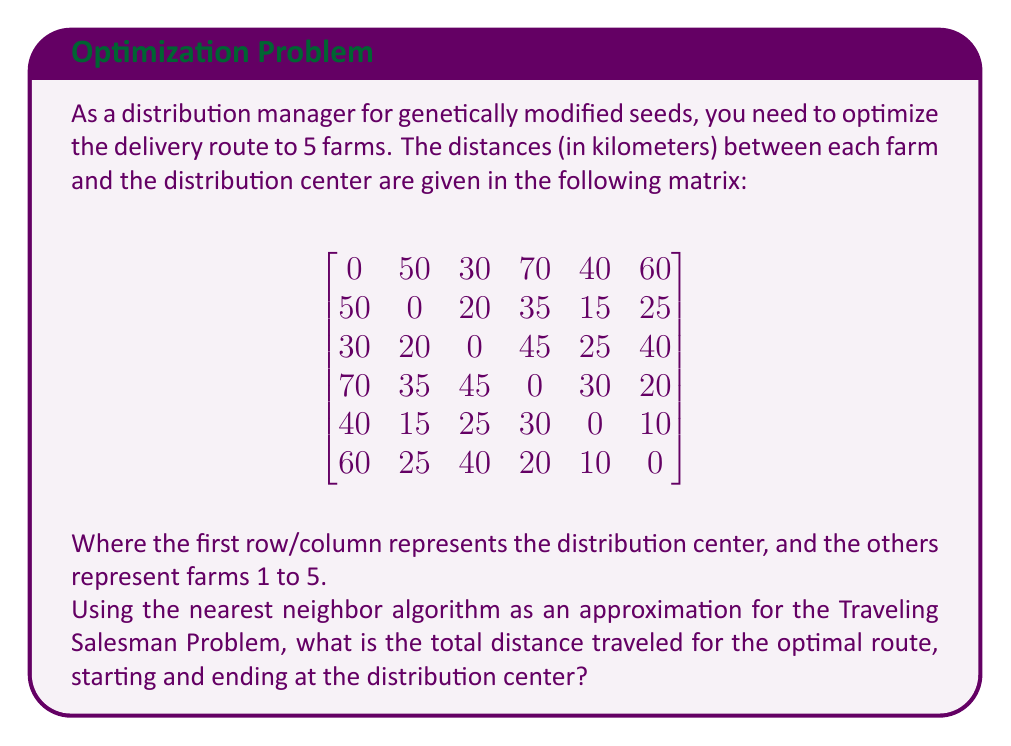Can you solve this math problem? To solve this problem using the nearest neighbor algorithm, we follow these steps:

1. Start at the distribution center (node 0).
2. Find the nearest unvisited node and move to it.
3. Repeat step 2 until all nodes have been visited.
4. Return to the distribution center.

Let's go through the process:

1. Start at node 0 (distribution center).
2. Nearest node to 0 is node 2 (30 km). Move to node 2.
3. Nearest unvisited node to 2 is node 1 (20 km). Move to node 1.
4. Nearest unvisited node to 1 is node 4 (15 km). Move to node 4.
5. Nearest unvisited node to 4 is node 5 (10 km). Move to node 5.
6. Only node 3 is left unvisited. Move to node 3 (20 km).
7. Return to the distribution center (node 0) from node 3 (70 km).

The route is: 0 → 2 → 1 → 4 → 5 → 3 → 0

To calculate the total distance:
$$\text{Total distance} = 30 + 20 + 15 + 10 + 20 + 70 = 165 \text{ km}$$
Answer: The total distance traveled for the optimal route using the nearest neighbor algorithm is 165 km. 